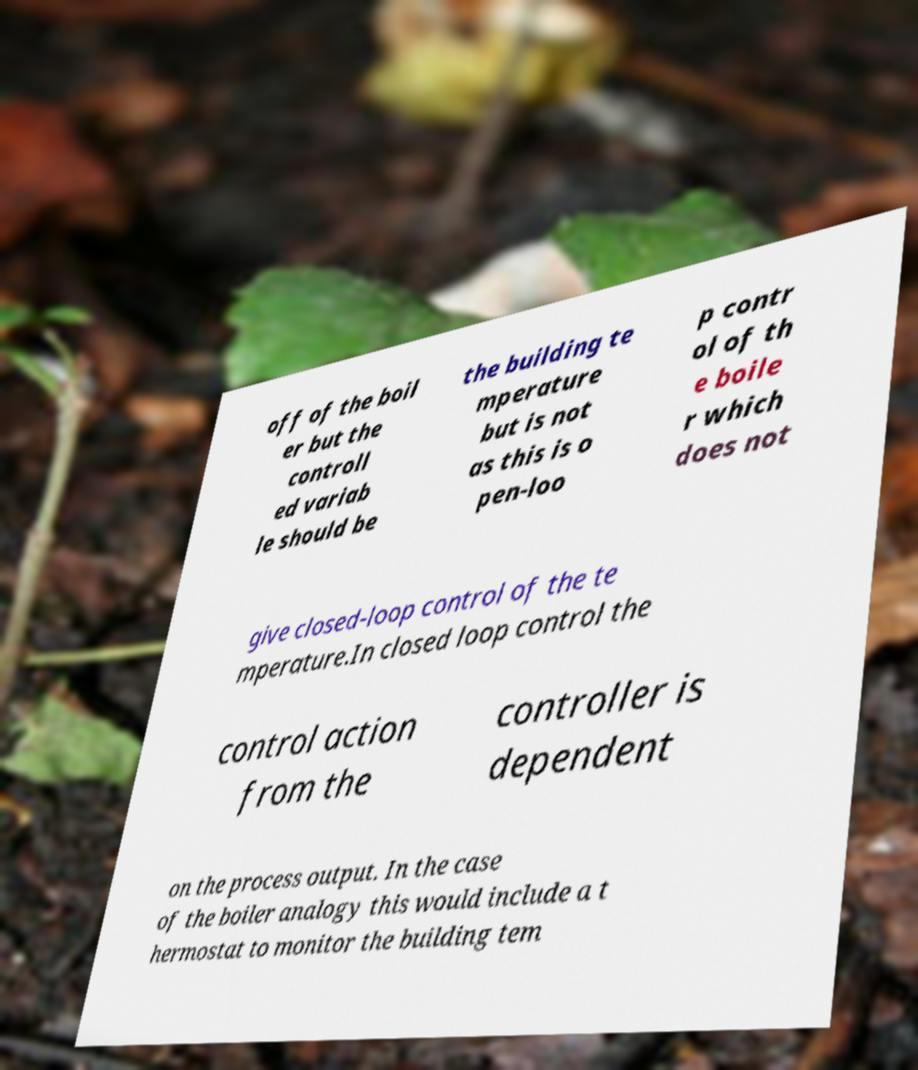What messages or text are displayed in this image? I need them in a readable, typed format. off of the boil er but the controll ed variab le should be the building te mperature but is not as this is o pen-loo p contr ol of th e boile r which does not give closed-loop control of the te mperature.In closed loop control the control action from the controller is dependent on the process output. In the case of the boiler analogy this would include a t hermostat to monitor the building tem 